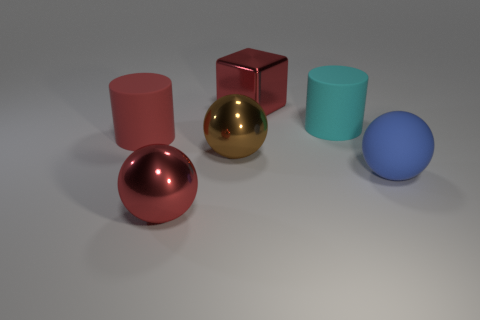Subtract 1 balls. How many balls are left? 2 Add 1 tiny cyan cubes. How many objects exist? 7 Subtract all cubes. How many objects are left? 5 Add 2 metallic blocks. How many metallic blocks are left? 3 Add 2 red metallic balls. How many red metallic balls exist? 3 Subtract 0 green cylinders. How many objects are left? 6 Subtract all small blocks. Subtract all shiny objects. How many objects are left? 3 